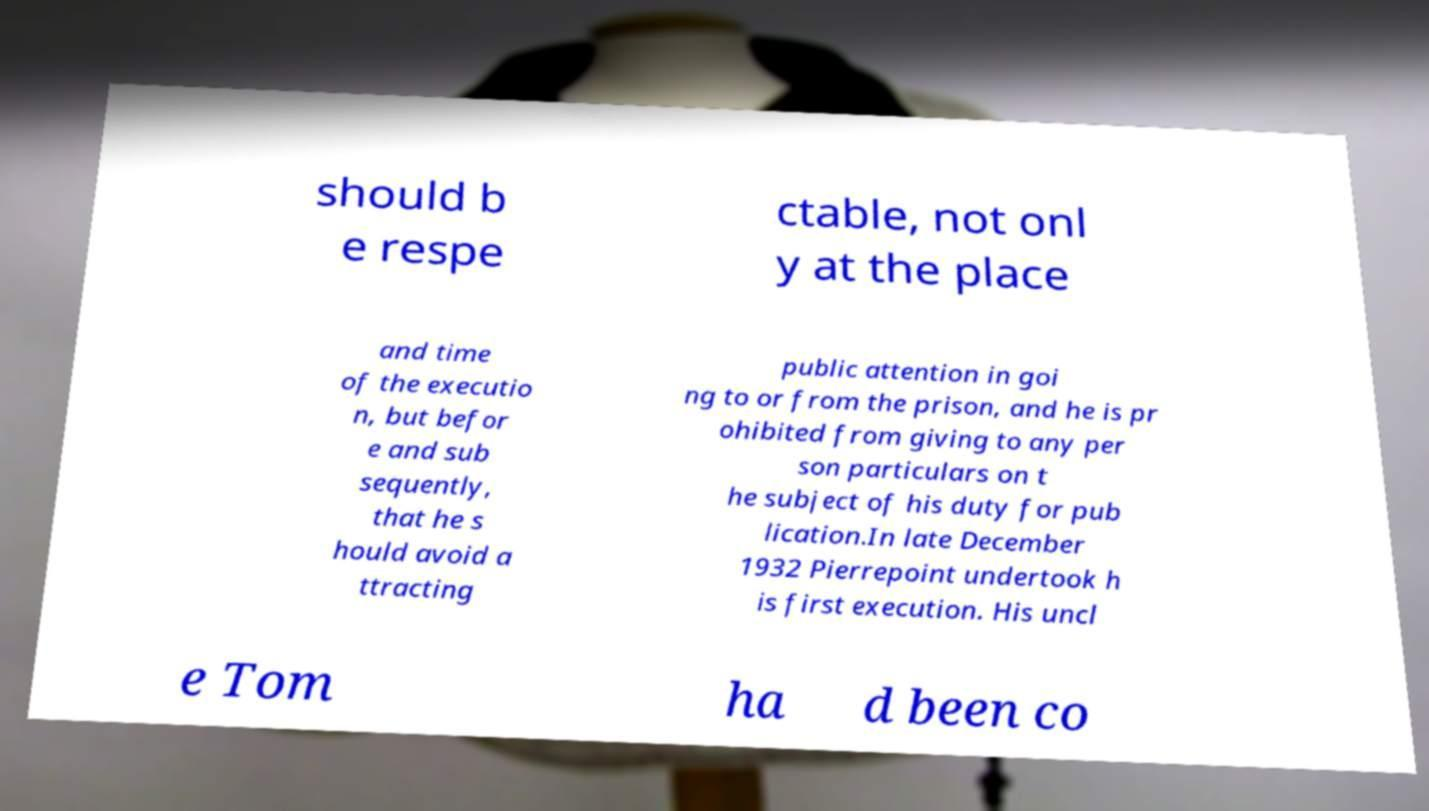Can you accurately transcribe the text from the provided image for me? should b e respe ctable, not onl y at the place and time of the executio n, but befor e and sub sequently, that he s hould avoid a ttracting public attention in goi ng to or from the prison, and he is pr ohibited from giving to any per son particulars on t he subject of his duty for pub lication.In late December 1932 Pierrepoint undertook h is first execution. His uncl e Tom ha d been co 